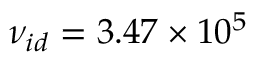Convert formula to latex. <formula><loc_0><loc_0><loc_500><loc_500>{ \nu _ { i d } } = 3 . 4 7 \times 1 0 ^ { 5 }</formula> 